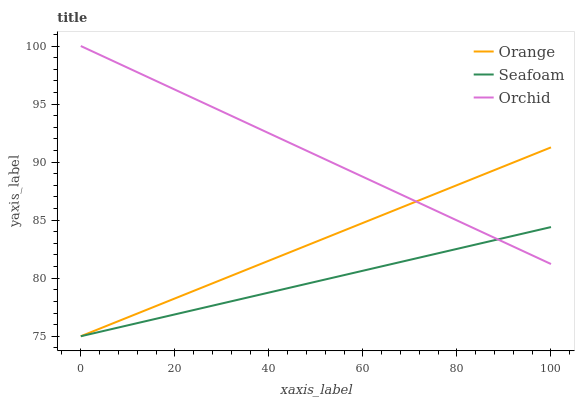Does Seafoam have the minimum area under the curve?
Answer yes or no. Yes. Does Orchid have the maximum area under the curve?
Answer yes or no. Yes. Does Orchid have the minimum area under the curve?
Answer yes or no. No. Does Seafoam have the maximum area under the curve?
Answer yes or no. No. Is Orchid the smoothest?
Answer yes or no. Yes. Is Orange the roughest?
Answer yes or no. Yes. Is Seafoam the smoothest?
Answer yes or no. No. Is Seafoam the roughest?
Answer yes or no. No. Does Orange have the lowest value?
Answer yes or no. Yes. Does Orchid have the lowest value?
Answer yes or no. No. Does Orchid have the highest value?
Answer yes or no. Yes. Does Seafoam have the highest value?
Answer yes or no. No. Does Orchid intersect Seafoam?
Answer yes or no. Yes. Is Orchid less than Seafoam?
Answer yes or no. No. Is Orchid greater than Seafoam?
Answer yes or no. No. 